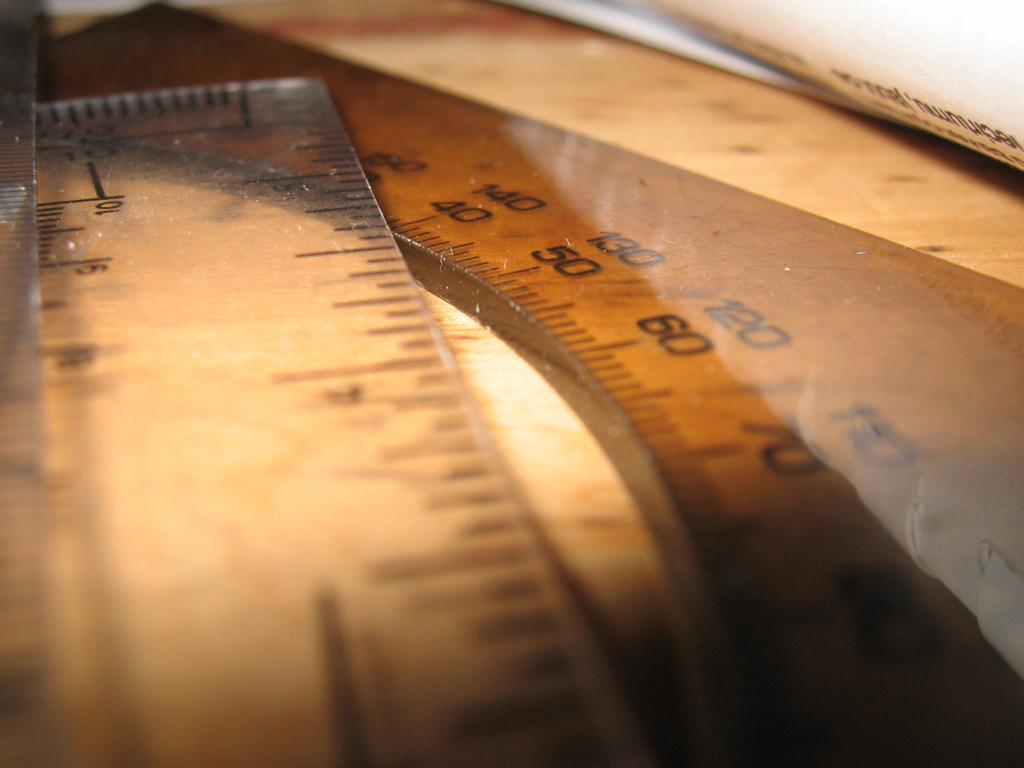What number is above 60?
Keep it short and to the point. 120. What is one of the numbers visible on these tools?
Make the answer very short. 50. 